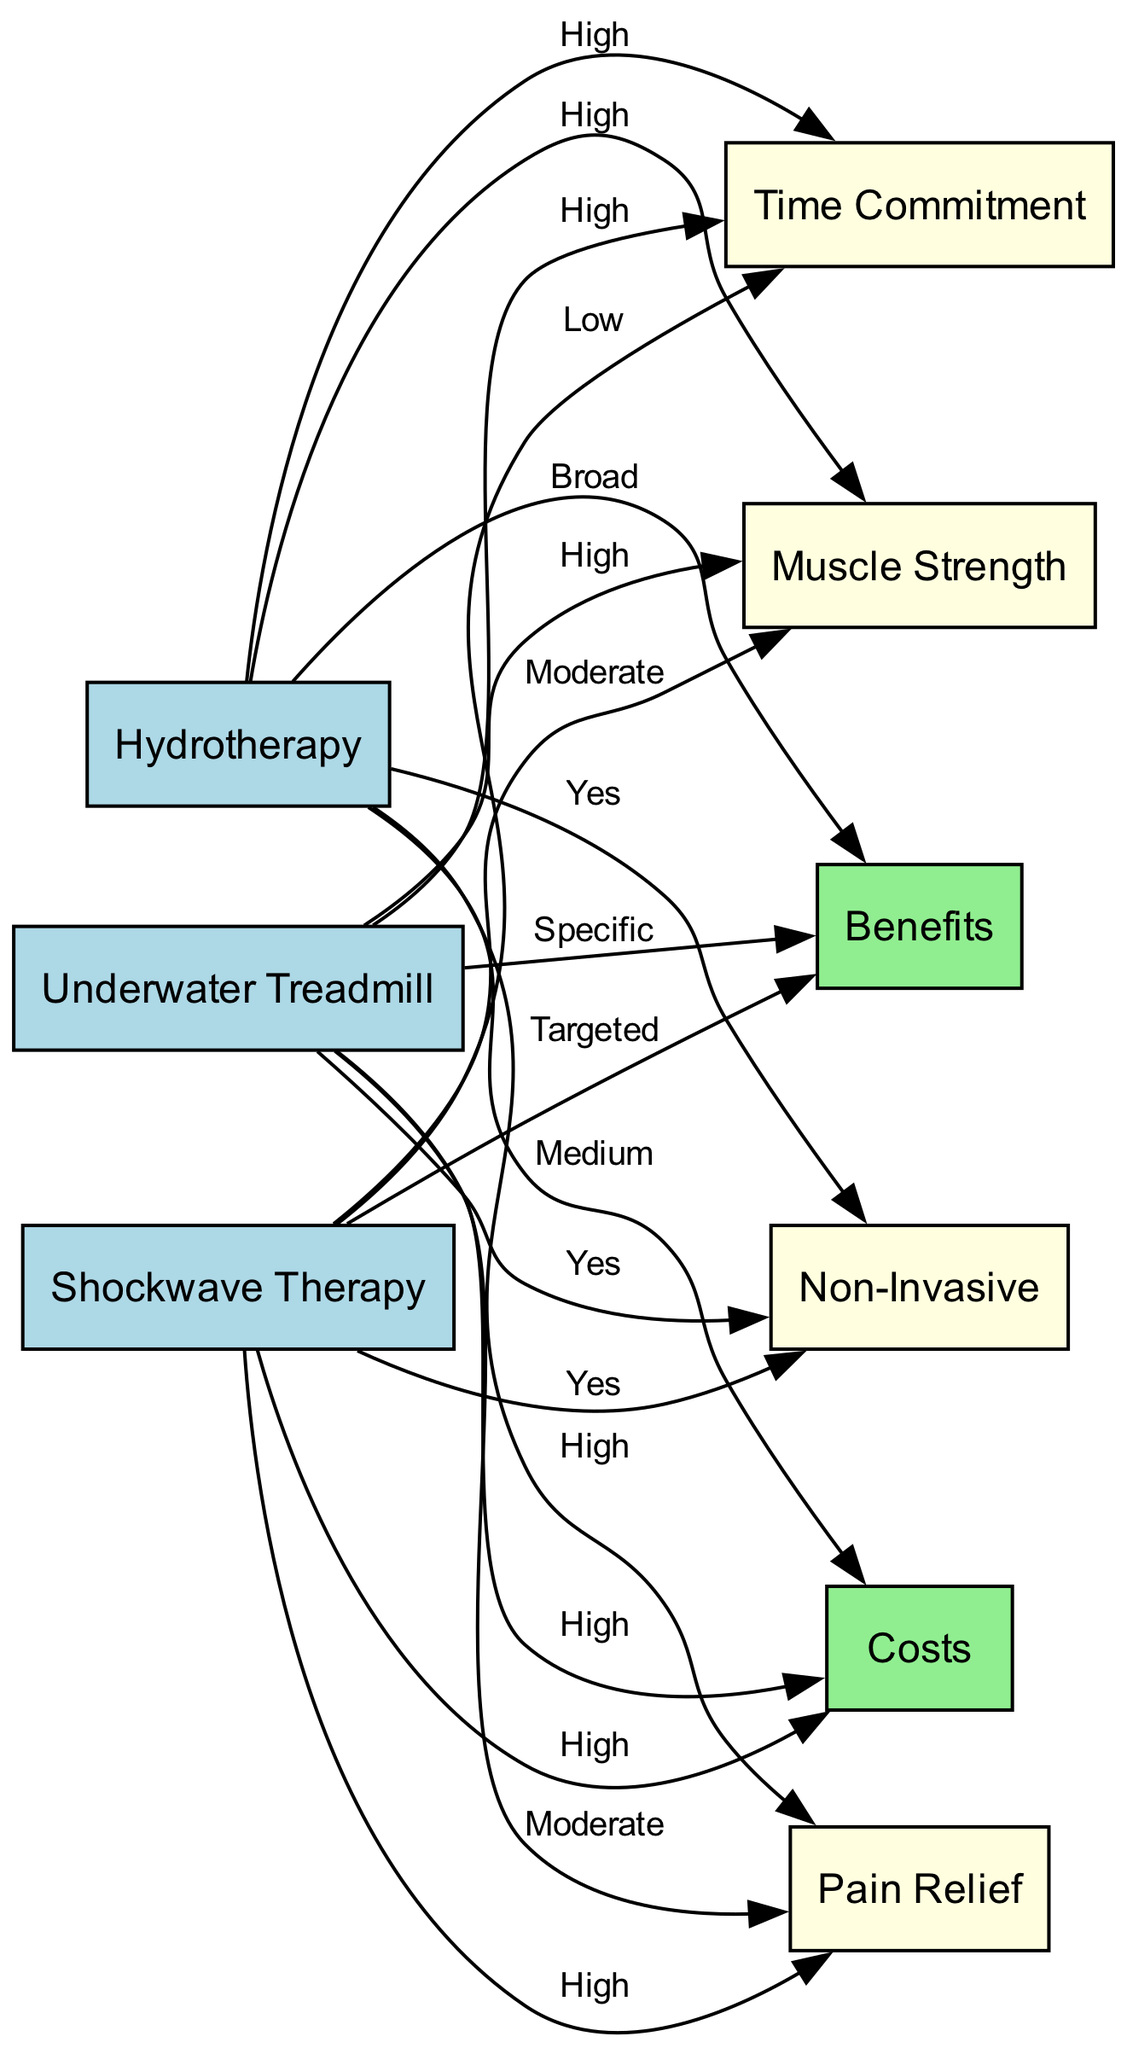What is the cost associated with hydrotherapy? The diagram indicates that the cost associated with hydrotherapy is labeled as "Medium." This can be found by tracing the edge from the "Hydrotherapy" node to the "Costs" node, where the label of the edge specifies the cost level.
Answer: Medium What are the benefits of the underwater treadmill? The diagram classifies the benefits of the underwater treadmill as "Specific." To find this information, we look at the edge leading from the "Treadmill" node to the "Benefits" node, where the label clearly states the nature of the benefits.
Answer: Specific Which rehabilitation equipment has the highest pain relief rating? By examining the edges connected to the "Pain Relief" node, hydrotherapy and shockwave therapy both have a "High" rating. However, comparing the two, hydrotherapy also ranks higher in overall benefits. Thus, the hydrotherapy is identified as having the highest pain relief.
Answer: Hydrotherapy What is the time commitment required for shockwave therapy? The diagram shows that the time commitment for shockwave therapy is labeled as "Low." This can be observed by tracing the edge from the "Shockwave" node to the "Time Commitment" node, where the label explicitly indicates the level of time investment required.
Answer: Low How many therapy types are classified as non-invasive? The diagram presents three therapy types: hydrotherapy, underwater treadmill, and shockwave therapy. All three are indicated to be non-invasive by their respective connections to the "Non-Invasive" node, where each edge confirms this characteristic. Thus, there are three types classified as non-invasive.
Answer: Three Which therapeutic equipment has a moderate pain relief benefit? Upon assessing the "Pain Relief" connections, the only equipment with a "Moderate" pain relief rating is the underwater treadmill. Both hydrotherapy and shockwave therapy have a higher rating, which differentiates the treadmill.
Answer: Underwater Treadmill What is the relationship between hydrotherapy and muscle strength? The diagram indicates a "High" level of muscle strength associated with hydrotherapy. This is answered by following the edge from the "Hydrotherapy" node to the "Muscle Strength" node, where the edge label provides the strength level associated with this therapy.
Answer: High Which rehabilitation method requires the highest time commitment? The diagram shows that both hydrotherapy and the underwater treadmill have a "High" time commitment. However, based on the nature of the benefits, hydrotherapy is suggested for more extensive use and thus could be seen as taking up more time overall.
Answer: Hydrotherapy 